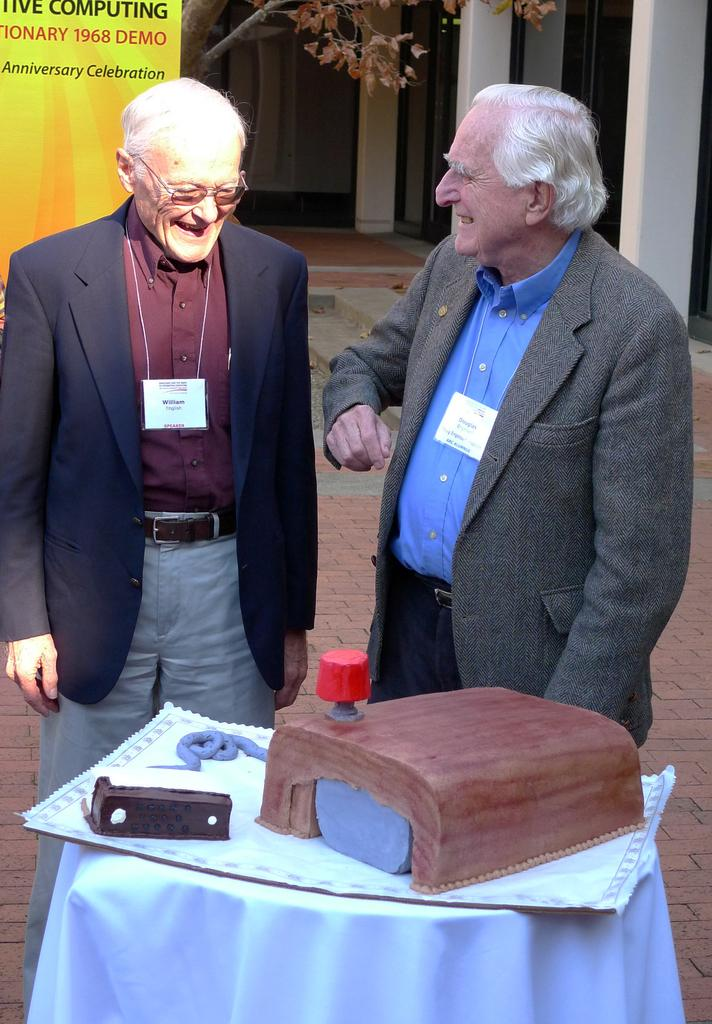How many people are present in the image? There are two persons standing in the image. What can be seen on the table in the image? There is a table with objects on it in the image. What is visible in the background of the image? There is a building in the background of the image. What type of eggs can be seen in the image? There are no eggs present in the image. What is the flock of birds doing in the image? There is no flock of birds present in the image. 